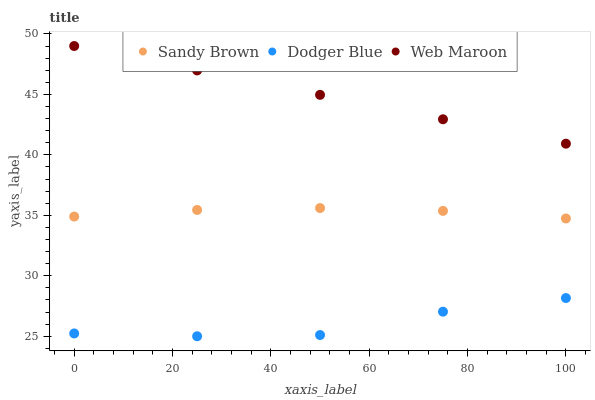Does Dodger Blue have the minimum area under the curve?
Answer yes or no. Yes. Does Web Maroon have the maximum area under the curve?
Answer yes or no. Yes. Does Sandy Brown have the minimum area under the curve?
Answer yes or no. No. Does Sandy Brown have the maximum area under the curve?
Answer yes or no. No. Is Web Maroon the smoothest?
Answer yes or no. Yes. Is Dodger Blue the roughest?
Answer yes or no. Yes. Is Sandy Brown the smoothest?
Answer yes or no. No. Is Sandy Brown the roughest?
Answer yes or no. No. Does Dodger Blue have the lowest value?
Answer yes or no. Yes. Does Sandy Brown have the lowest value?
Answer yes or no. No. Does Web Maroon have the highest value?
Answer yes or no. Yes. Does Sandy Brown have the highest value?
Answer yes or no. No. Is Dodger Blue less than Web Maroon?
Answer yes or no. Yes. Is Sandy Brown greater than Dodger Blue?
Answer yes or no. Yes. Does Dodger Blue intersect Web Maroon?
Answer yes or no. No. 